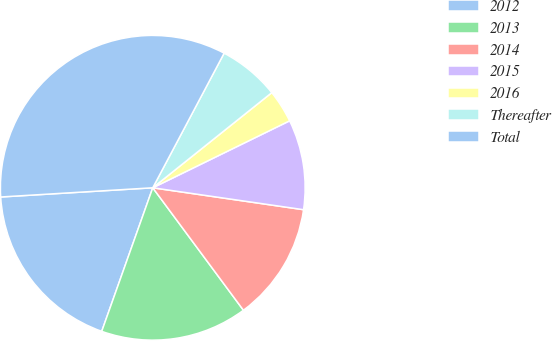Convert chart to OTSL. <chart><loc_0><loc_0><loc_500><loc_500><pie_chart><fcel>2012<fcel>2013<fcel>2014<fcel>2015<fcel>2016<fcel>Thereafter<fcel>Total<nl><fcel>18.6%<fcel>15.58%<fcel>12.56%<fcel>9.54%<fcel>3.49%<fcel>6.51%<fcel>33.72%<nl></chart> 